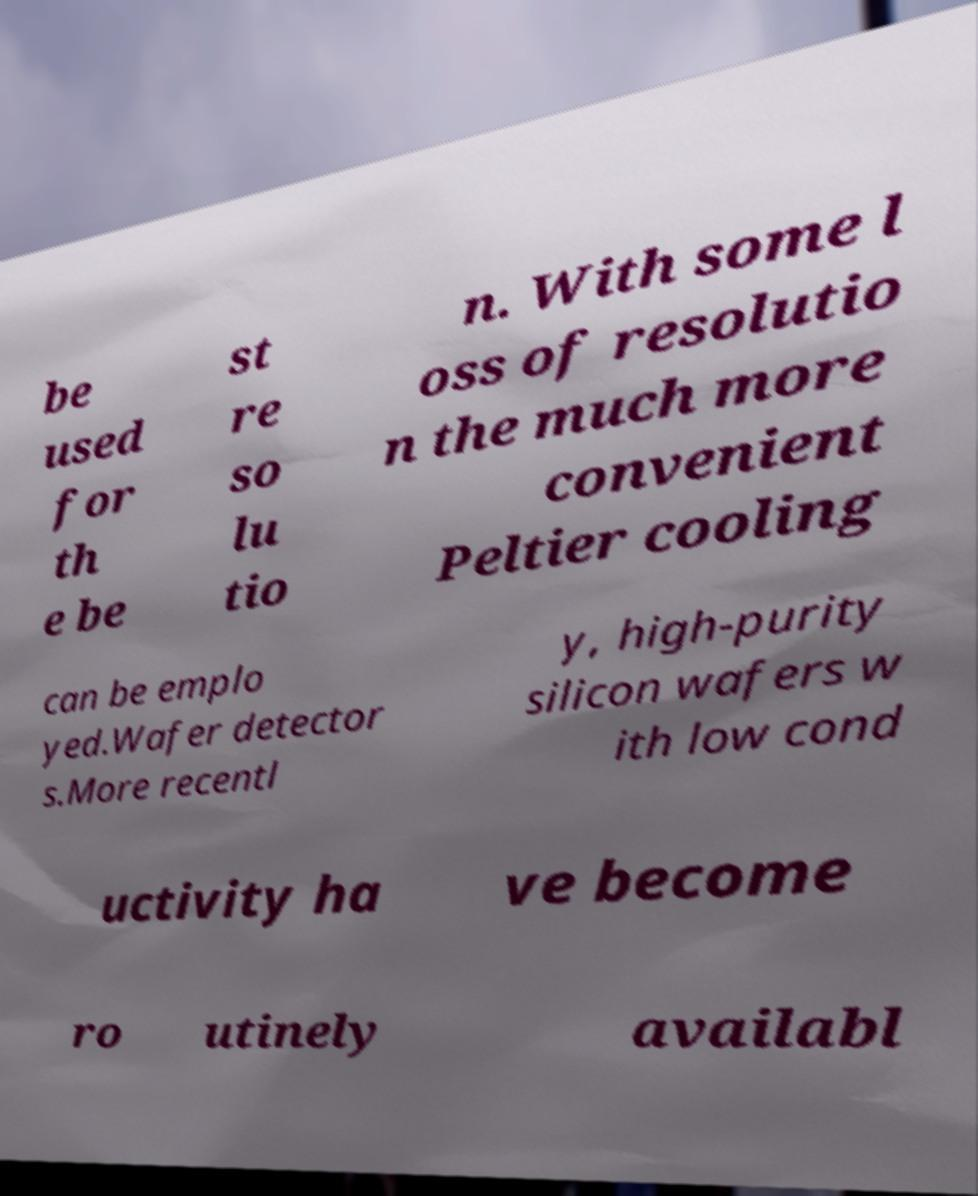Could you assist in decoding the text presented in this image and type it out clearly? be used for th e be st re so lu tio n. With some l oss of resolutio n the much more convenient Peltier cooling can be emplo yed.Wafer detector s.More recentl y, high-purity silicon wafers w ith low cond uctivity ha ve become ro utinely availabl 